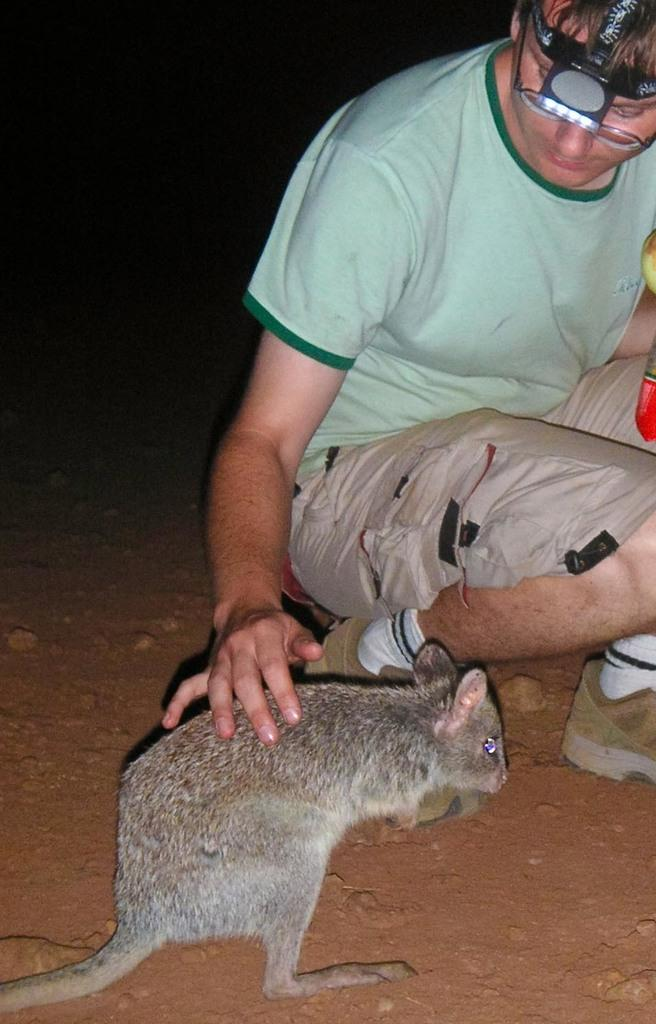Who is the main subject in the image? There is a boy in the image. What is the boy doing in the image? The boy is sitting on the floor. Where is the boy located in the image? The boy is on the right side of the image. What is the boy doing with his hand in the image? The boy is placing his hand on a rat. Where is the rat located in the image? The rat is at the bottom side of the image. What type of tiger can be seen in the image? There is no tiger present in the image. 